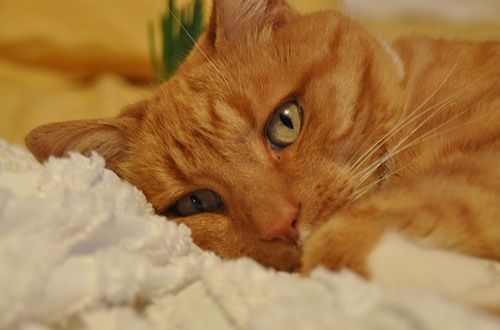Describe the objects in this image and their specific colors. I can see a cat in olive, brown, maroon, and tan tones in this image. 